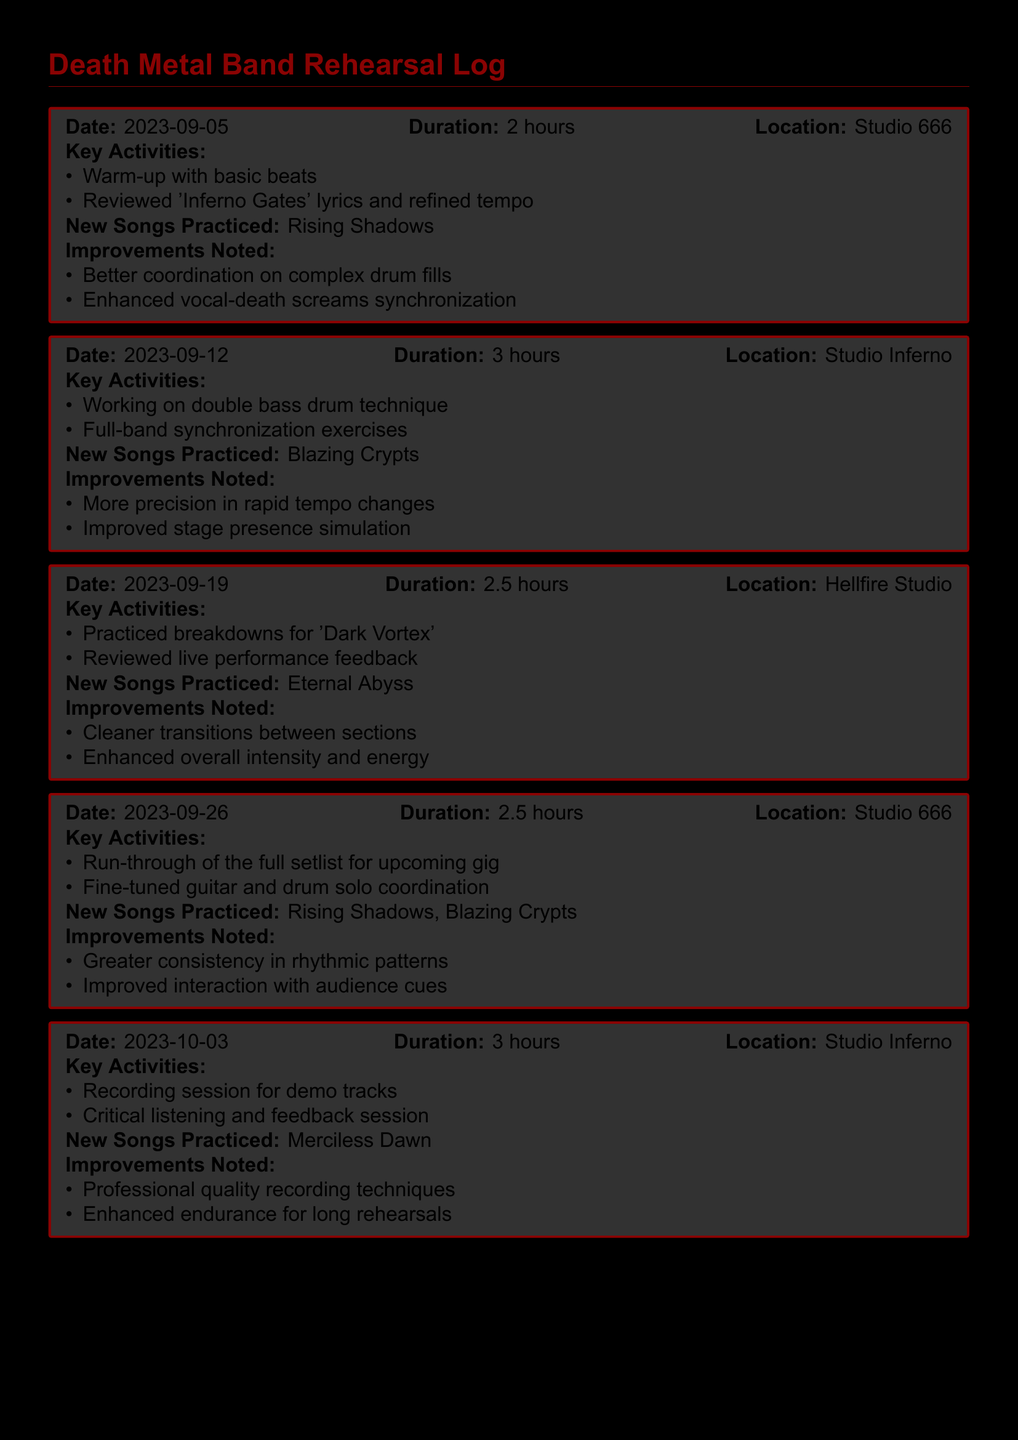What was the duration of the session on September 12, 2023? The duration is specified in the log entry for that date as 3 hours.
Answer: 3 hours Where did the band rehearse on October 3, 2023? The location is indicated in the session entry for that date as Studio Inferno.
Answer: Studio Inferno What new song was practiced during the session on September 26, 2023? The new song is mentioned in the log entry for that date as Rising Shadows and Blazing Crypts.
Answer: Rising Shadows, Blazing Crypts What key activity involved critical listening and feedback session? This key activity is noted in the session entry for October 3, 2023.
Answer: Recording session for demo tracks How many total hours were spent rehearsing on September 5 and 12 combined? The total duration is the sum of 2 hours and 3 hours from those sessions.
Answer: 5 hours Which song practiced on September 19 shows improvements in transitions? The song improved is listed in the entry for September 19 as Eternal Abyss.
Answer: Eternal Abyss What improvement was noted regarding performance in the rehearsal on September 26? An improvement concerning performance is specified as improved interaction with audience cues.
Answer: Improved interaction with audience cues On which date did the band practice 'Dark Vortex'? The date is identified in the entry as September 19, 2023.
Answer: September 19, 2023 